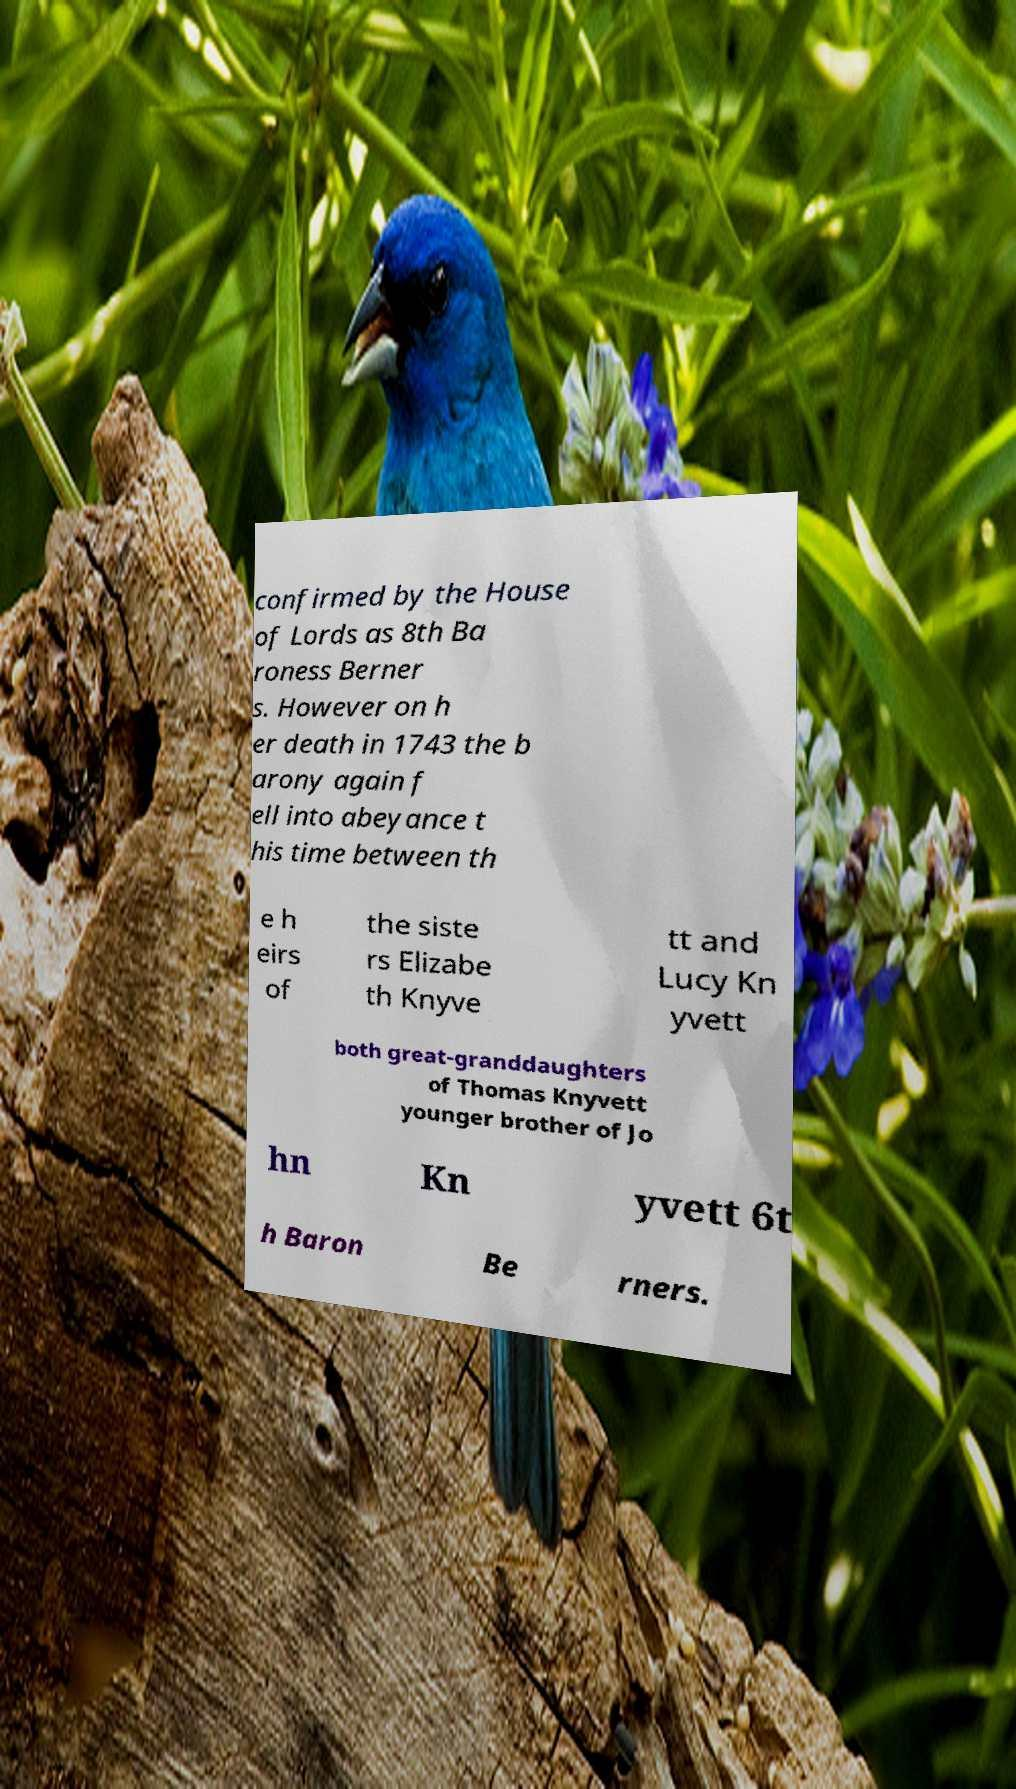For documentation purposes, I need the text within this image transcribed. Could you provide that? confirmed by the House of Lords as 8th Ba roness Berner s. However on h er death in 1743 the b arony again f ell into abeyance t his time between th e h eirs of the siste rs Elizabe th Knyve tt and Lucy Kn yvett both great-granddaughters of Thomas Knyvett younger brother of Jo hn Kn yvett 6t h Baron Be rners. 